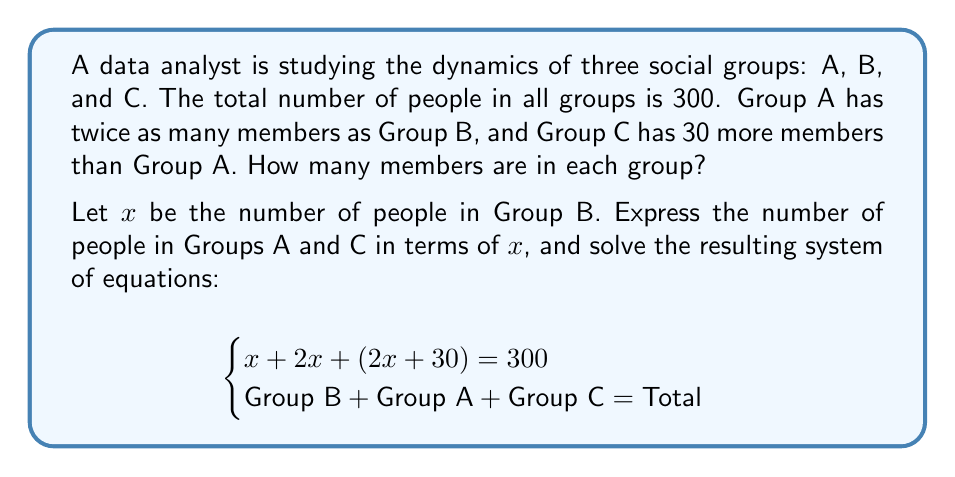Teach me how to tackle this problem. Let's solve this step-by-step:

1) We have the equation: $x + 2x + (2x + 30) = 300$

2) Simplify the left side of the equation:
   $x + 2x + 2x + 30 = 300$
   $5x + 30 = 300$

3) Subtract 30 from both sides:
   $5x = 270$

4) Divide both sides by 5:
   $x = 54$

5) Now that we know $x$, we can find the number of people in each group:
   Group B: $x = 54$
   Group A: $2x = 2(54) = 108$
   Group C: $2x + 30 = 2(54) + 30 = 108 + 30 = 138$

6) Verify the solution:
   $54 + 108 + 138 = 300$ (Total checks out)

Therefore, Group A has 108 members, Group B has 54 members, and Group C has 138 members.
Answer: Group A: 108, Group B: 54, Group C: 138 